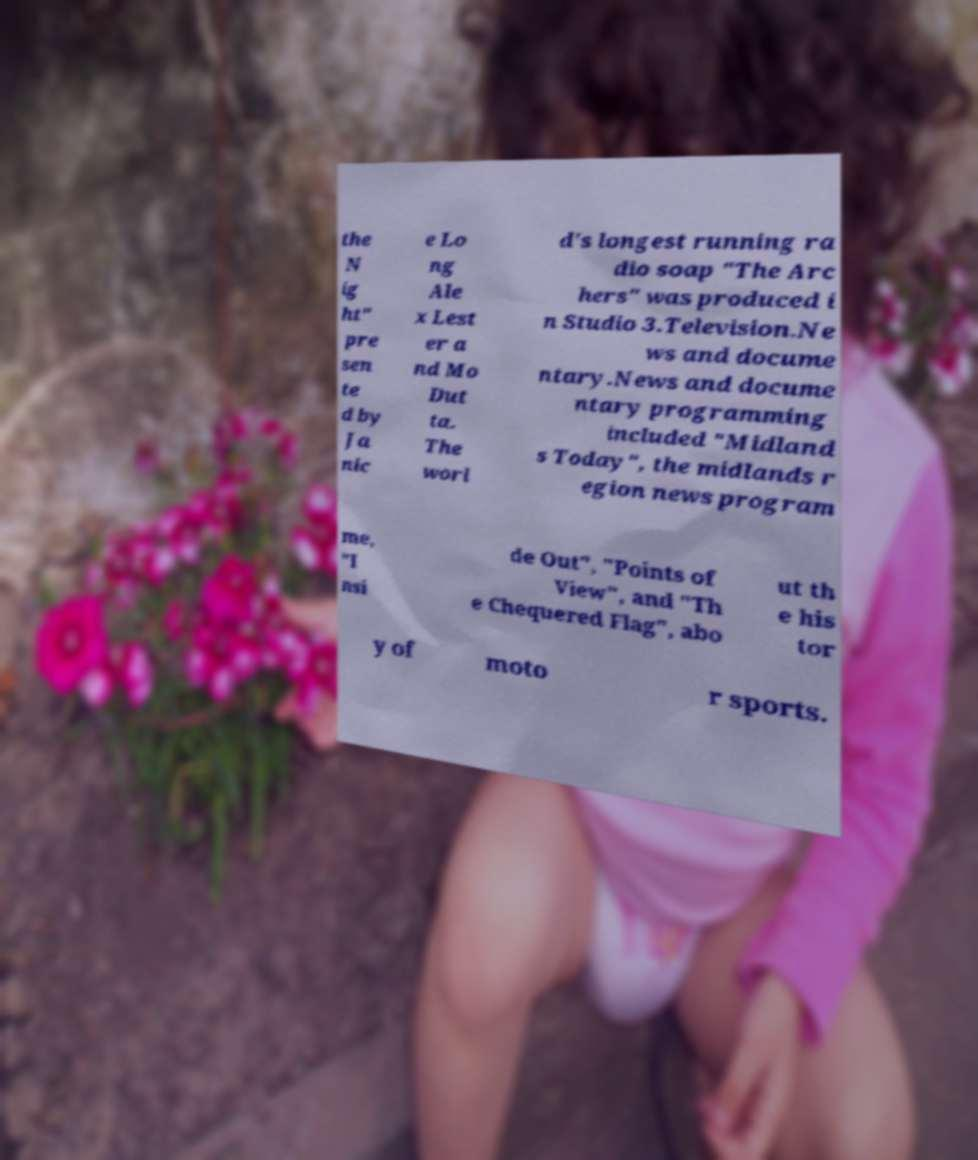Can you accurately transcribe the text from the provided image for me? the N ig ht" pre sen te d by Ja nic e Lo ng Ale x Lest er a nd Mo Dut ta. The worl d's longest running ra dio soap "The Arc hers" was produced i n Studio 3.Television.Ne ws and docume ntary.News and docume ntary programming included "Midland s Today", the midlands r egion news program me, "I nsi de Out", "Points of View", and "Th e Chequered Flag", abo ut th e his tor y of moto r sports. 